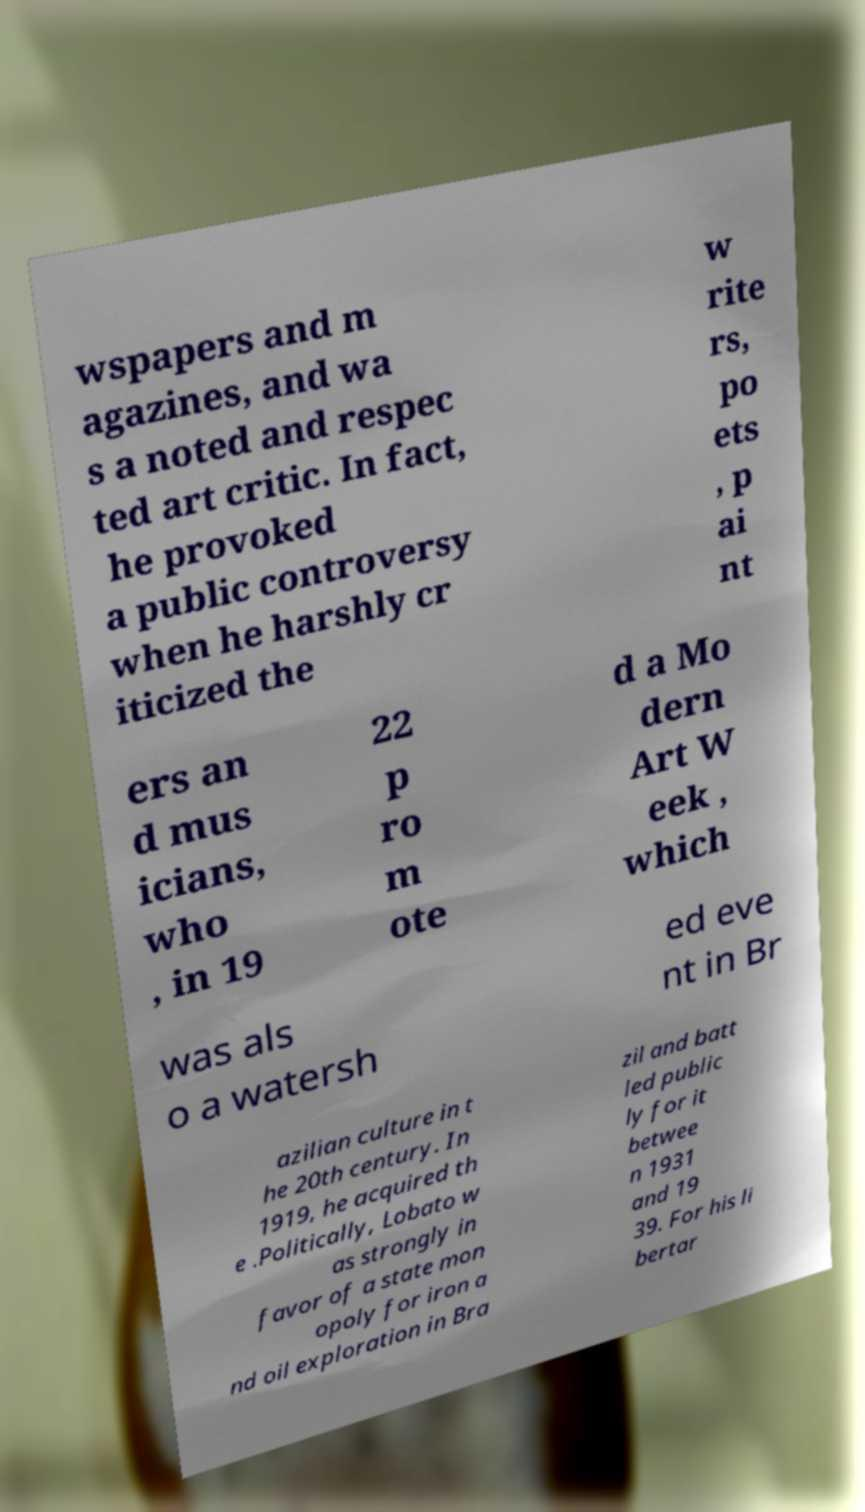Please read and relay the text visible in this image. What does it say? wspapers and m agazines, and wa s a noted and respec ted art critic. In fact, he provoked a public controversy when he harshly cr iticized the w rite rs, po ets , p ai nt ers an d mus icians, who , in 19 22 p ro m ote d a Mo dern Art W eek , which was als o a watersh ed eve nt in Br azilian culture in t he 20th century. In 1919, he acquired th e .Politically, Lobato w as strongly in favor of a state mon opoly for iron a nd oil exploration in Bra zil and batt led public ly for it betwee n 1931 and 19 39. For his li bertar 